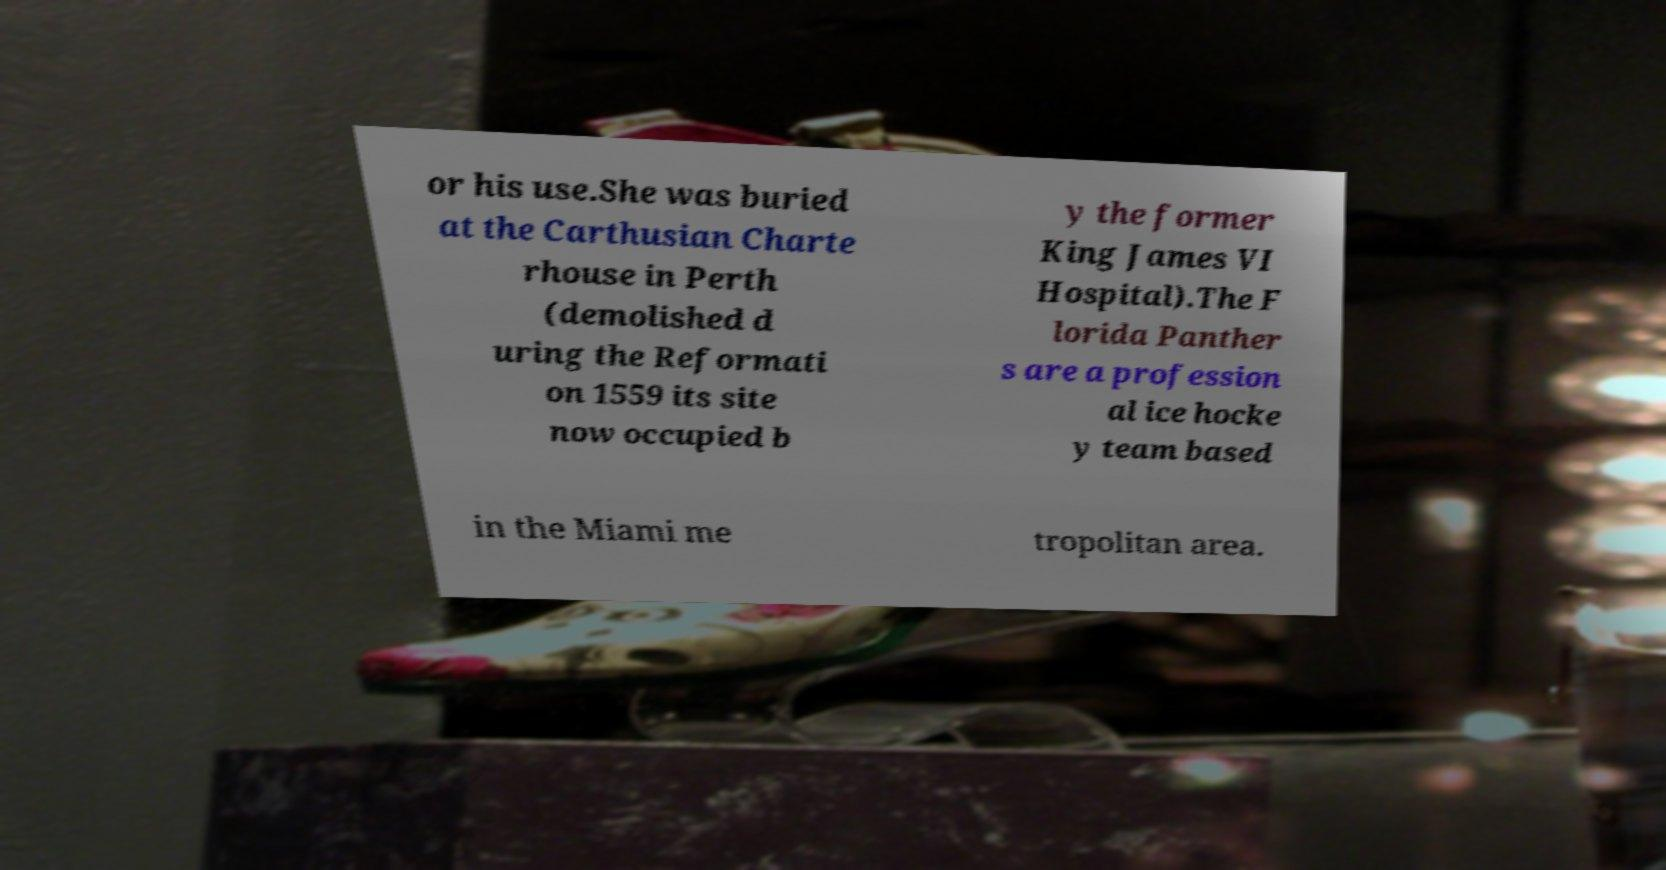Could you assist in decoding the text presented in this image and type it out clearly? or his use.She was buried at the Carthusian Charte rhouse in Perth (demolished d uring the Reformati on 1559 its site now occupied b y the former King James VI Hospital).The F lorida Panther s are a profession al ice hocke y team based in the Miami me tropolitan area. 